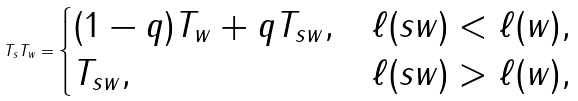<formula> <loc_0><loc_0><loc_500><loc_500>T _ { s } T _ { w } = \begin{cases} ( 1 - q ) T _ { w } + q T _ { s w } , & \ell ( s w ) < \ell ( w ) , \\ T _ { s w } , & \ell ( s w ) > \ell ( w ) , \end{cases}</formula> 